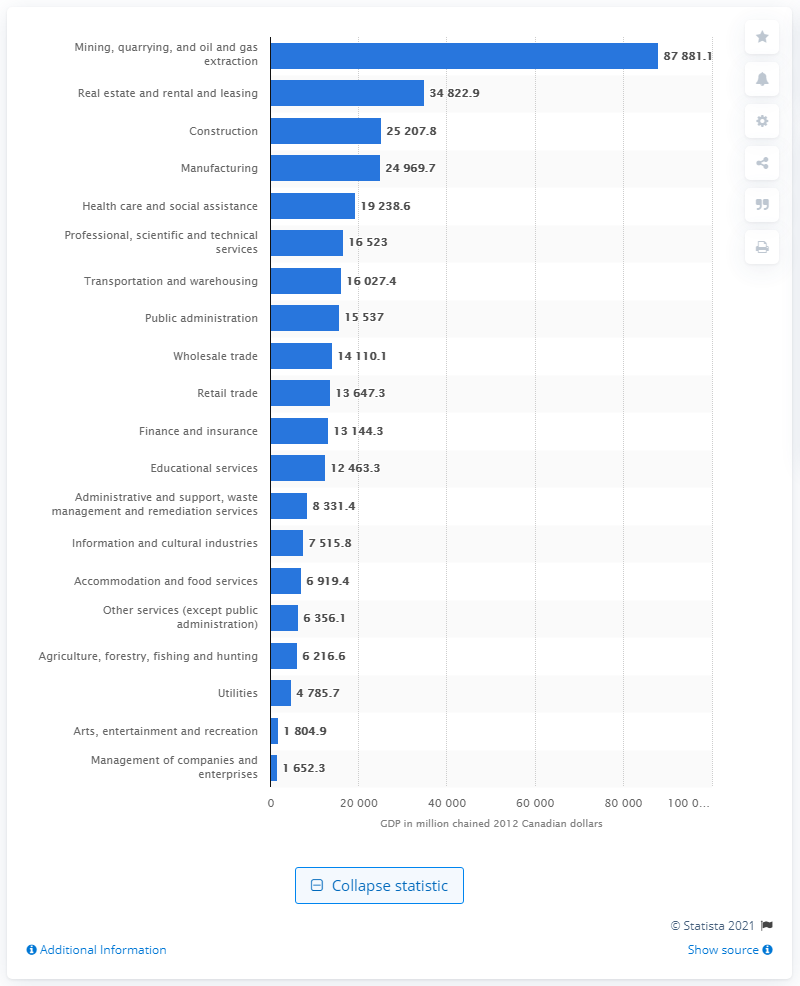Specify some key components in this picture. In 2019, the Gross Domestic Product (GDP) of the construction industry in Alberta was 25,207.8 million dollars. 